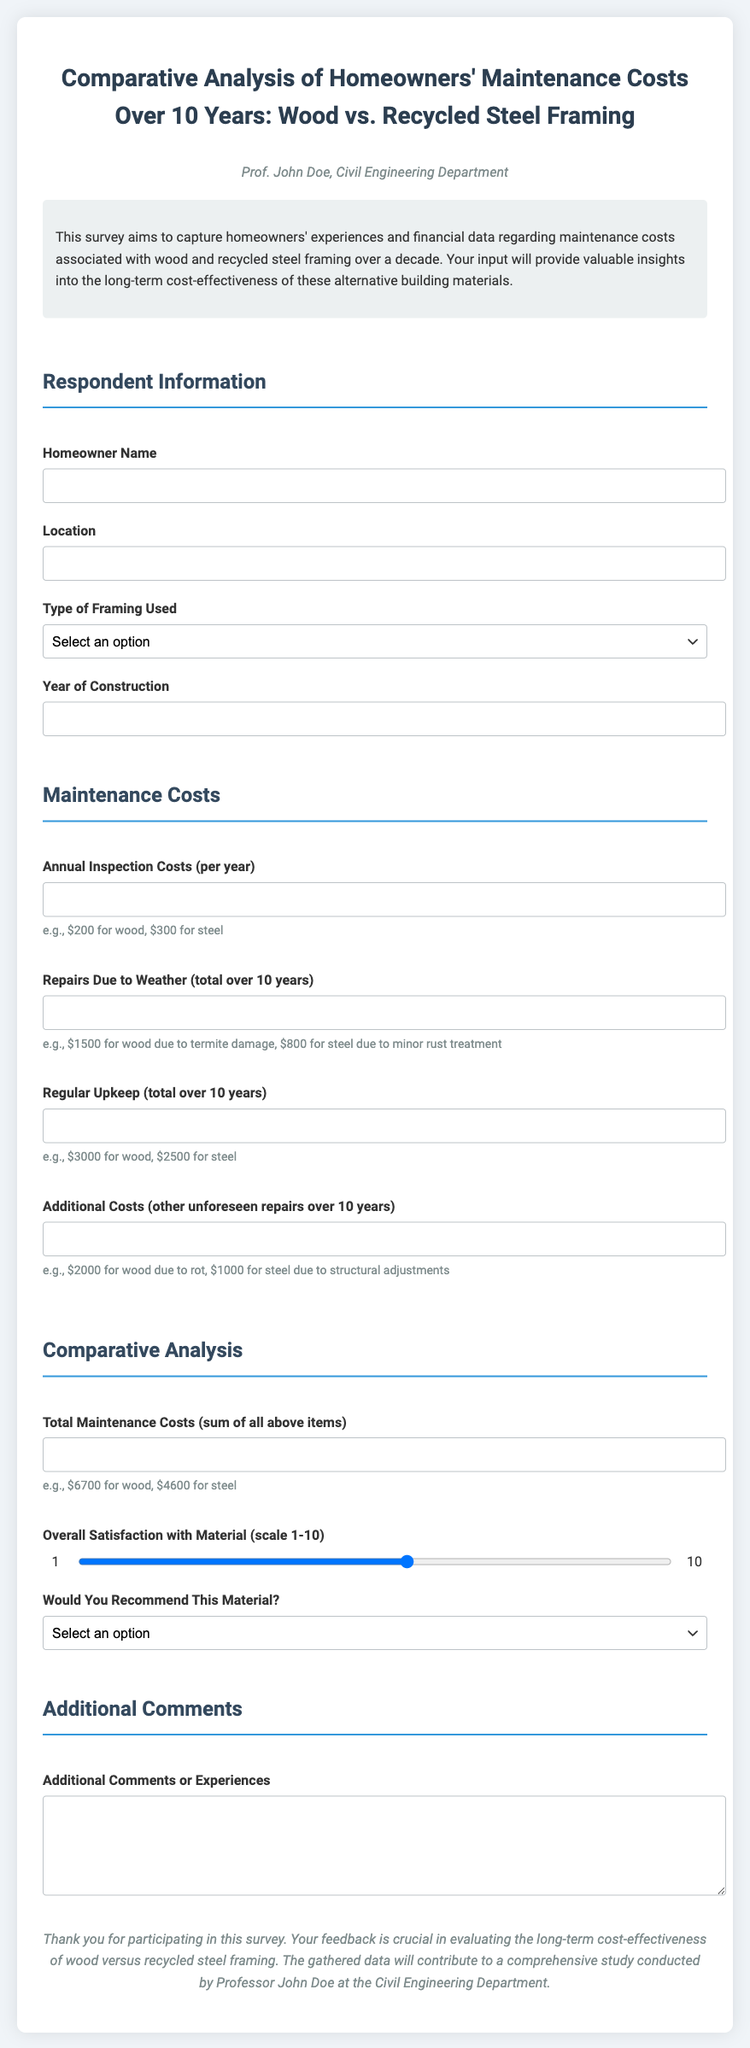what is the title of the survey? The title is prominently displayed at the top of the document, identifying the subject of the survey.
Answer: Comparative Analysis of Homeowners' Maintenance Costs Over 10 Years: Wood vs. Recycled Steel Framing who conducted the survey? The instructor's name is mentioned to indicate who is conducting the survey.
Answer: Prof. John Doe what is the example given for annual inspection costs? The document provides an example for this question in its description to guide respondents.
Answer: e.g., $200 for wood, $300 for steel how many years does the survey cover for maintenance costs? The duration of the survey is specified within the title and introductory paragraph.
Answer: 10 years what is the range for overall satisfaction with the material? The document specifies the scale for satisfaction to guide the respondents in their answers.
Answer: 1-10 what option is available for the type of framing used? The survey allows homeowners to select their type of framing when responding.
Answer: Wood, Recycled Steel what is the total maintenance costs example provided for wood? The survey gives an example of the total maintenance costs expected for clarity.
Answer: e.g., $6700 for wood is a recommendation option provided in the survey? Yes, the survey includes choices for participants regarding their recommendation of the material.
Answer: Yes what is the background color of the document? The document has a specific background color that is consistent throughout.
Answer: #f0f4f8 